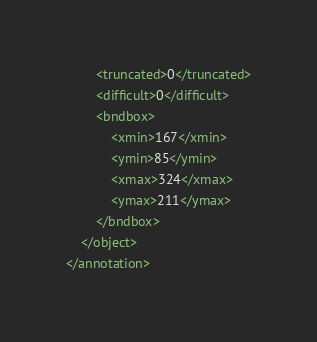<code> <loc_0><loc_0><loc_500><loc_500><_XML_>		<truncated>0</truncated>
		<difficult>0</difficult>
		<bndbox>
			<xmin>167</xmin>
			<ymin>85</ymin>
			<xmax>324</xmax>
			<ymax>211</ymax>
		</bndbox>
	</object>
</annotation></code> 